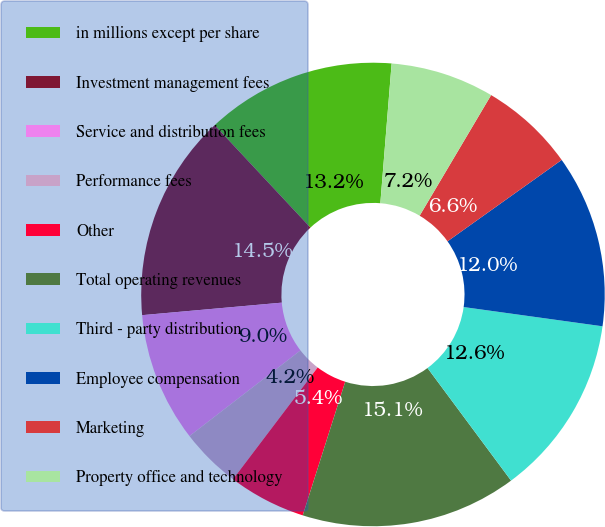<chart> <loc_0><loc_0><loc_500><loc_500><pie_chart><fcel>in millions except per share<fcel>Investment management fees<fcel>Service and distribution fees<fcel>Performance fees<fcel>Other<fcel>Total operating revenues<fcel>Third - party distribution<fcel>Employee compensation<fcel>Marketing<fcel>Property office and technology<nl><fcel>13.25%<fcel>14.46%<fcel>9.04%<fcel>4.22%<fcel>5.42%<fcel>15.06%<fcel>12.65%<fcel>12.05%<fcel>6.63%<fcel>7.23%<nl></chart> 